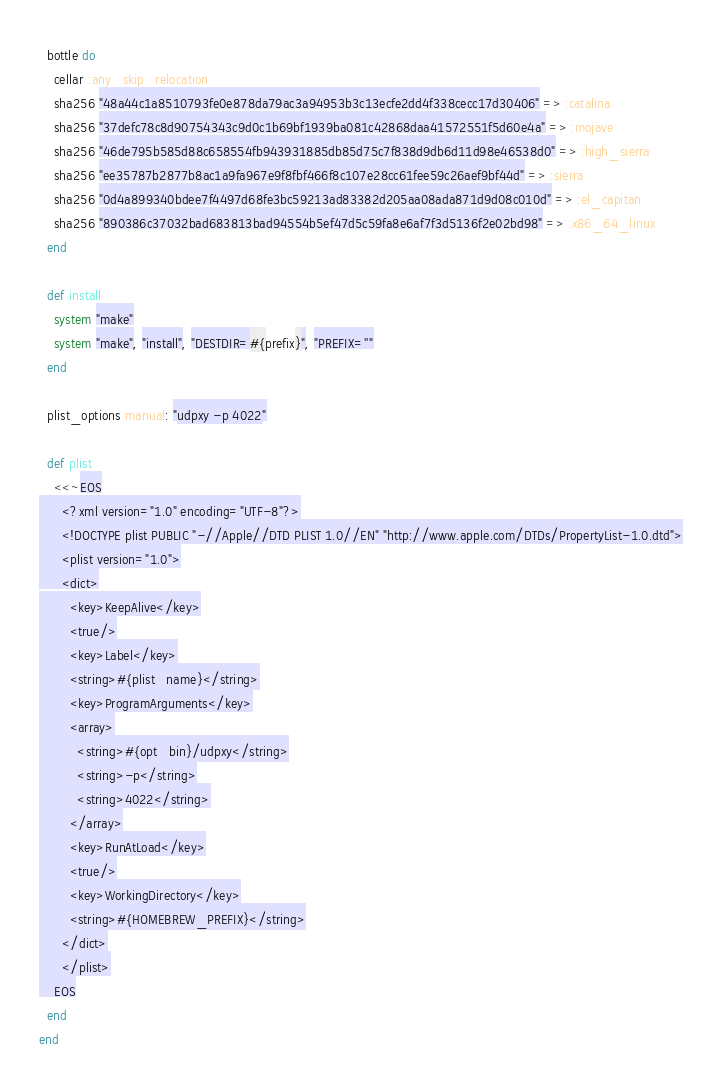Convert code to text. <code><loc_0><loc_0><loc_500><loc_500><_Ruby_>
  bottle do
    cellar :any_skip_relocation
    sha256 "48a44c1a8510793fe0e878da79ac3a94953b3c13ecfe2dd4f338cecc17d30406" => :catalina
    sha256 "37defc78c8d90754343c9d0c1b69bf1939ba081c42868daa41572551f5d60e4a" => :mojave
    sha256 "46de795b585d88c658554fb943931885db85d75c7f838d9db6d11d98e46538d0" => :high_sierra
    sha256 "ee35787b2877b8ac1a9fa967e9f8fbf466f8c107e28cc61fee59c26aef9bf44d" => :sierra
    sha256 "0d4a899340bdee7f4497d68fe3bc59213ad83382d205aa08ada871d9d08c010d" => :el_capitan
    sha256 "890386c37032bad683813bad94554b5ef47d5c59fa8e6af7f3d5136f2e02bd98" => :x86_64_linux
  end

  def install
    system "make"
    system "make", "install", "DESTDIR=#{prefix}", "PREFIX=''"
  end

  plist_options manual: "udpxy -p 4022"

  def plist
    <<~EOS
      <?xml version="1.0" encoding="UTF-8"?>
      <!DOCTYPE plist PUBLIC "-//Apple//DTD PLIST 1.0//EN" "http://www.apple.com/DTDs/PropertyList-1.0.dtd">
      <plist version="1.0">
      <dict>
        <key>KeepAlive</key>
        <true/>
        <key>Label</key>
        <string>#{plist_name}</string>
        <key>ProgramArguments</key>
        <array>
          <string>#{opt_bin}/udpxy</string>
          <string>-p</string>
          <string>4022</string>
        </array>
        <key>RunAtLoad</key>
        <true/>
        <key>WorkingDirectory</key>
        <string>#{HOMEBREW_PREFIX}</string>
      </dict>
      </plist>
    EOS
  end
end
</code> 